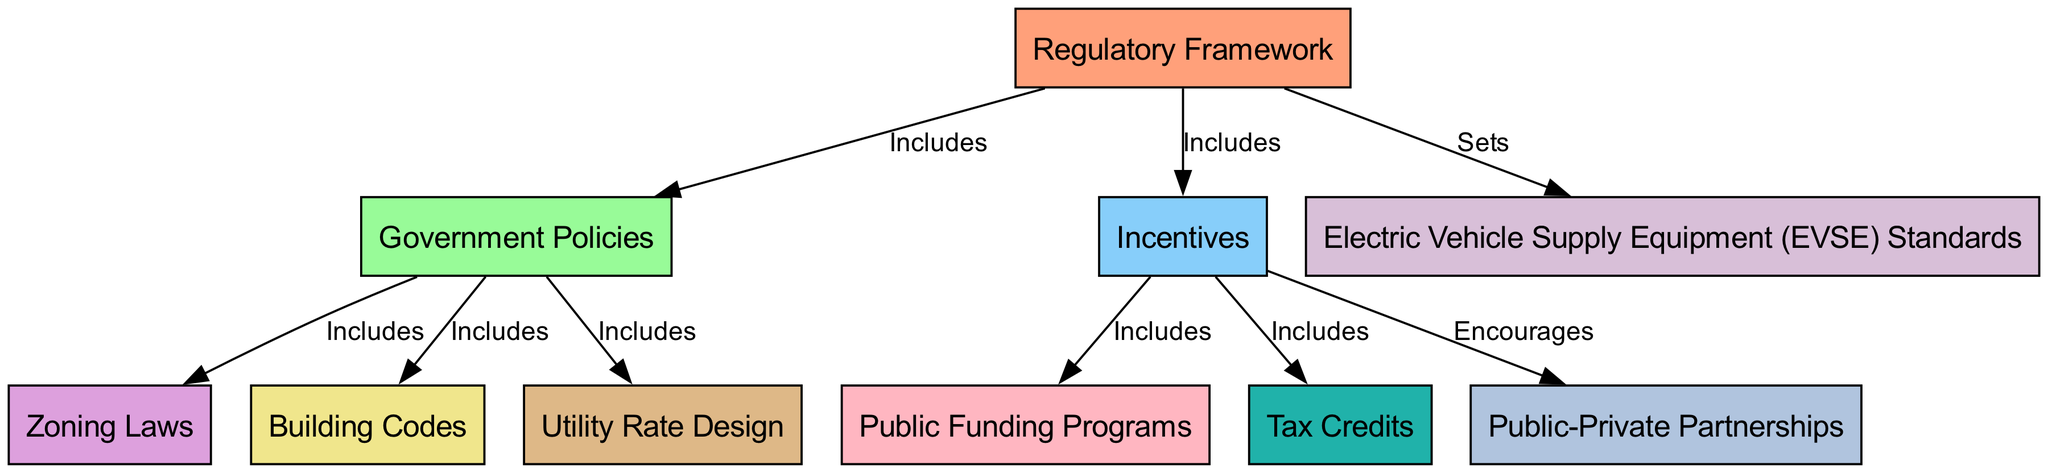What is the central theme of the diagram? The diagram focuses on the "Regulatory Framework" as the central node, which includes various components like government policies and incentives relevant to electric vehicle charging infrastructure.
Answer: Regulatory Framework How many nodes are present in the diagram? By counting the unique labels or entities depicted in the diagram, we identify ten distinct nodes that represent different aspects of the regulatory framework.
Answer: 10 What type of relationship exists between "Government Policies" and "Zoning Laws"? The edge from "Government Policies" to "Zoning Laws" indicates that zoning laws are a component included within government policies concerning electric vehicle infrastructure.
Answer: Includes Name one incentive associated with tax reduction in the diagram. The diagram indicates "Tax Credits" as a specific incentive linked to government initiatives that facilitate the adoption of electric vehicles.
Answer: Tax Credits Which node is specifically associated with setting standards? The edge from "Regulatory Framework" to "Electric Vehicle Supply Equipment (EVSE) Standards" shows that this node is responsible for setting the standards related to electric vehicle supply equipment.
Answer: Electric Vehicle Supply Equipment (EVSE) Standards How does "Public-Private Partnerships" relate to "Incentives"? The diagram displays that "Public-Private Partnerships" are encouraged as part of the incentives to promote collaboration in the development of electric vehicle infrastructure, indicating a supportive relationship.
Answer: Encourages What are the two categories included under "Incentives"? The edges indicate that "Public Funding Programs" and "Tax Credits" are the two main categorizations of incentives associated with electric vehicles, which are detail-oriented and supportive of infrastructure developement.
Answer: Public Funding Programs, Tax Credits How many types of government policies are mentioned in the diagram? By analyzing the nodes connected to "Government Policies", we discern three types: zoning laws, building codes, and utility rate design, thus indicating the representation of three distinct types of government policies.
Answer: 3 Which node does "Utility Rate Design" belong to? The edge from "Government Policies" to "Utility Rate Design" demonstrates that it is part of the government policies related to electric vehicle charging, indicating its categorization accordingly within the framework.
Answer: Government Policies 